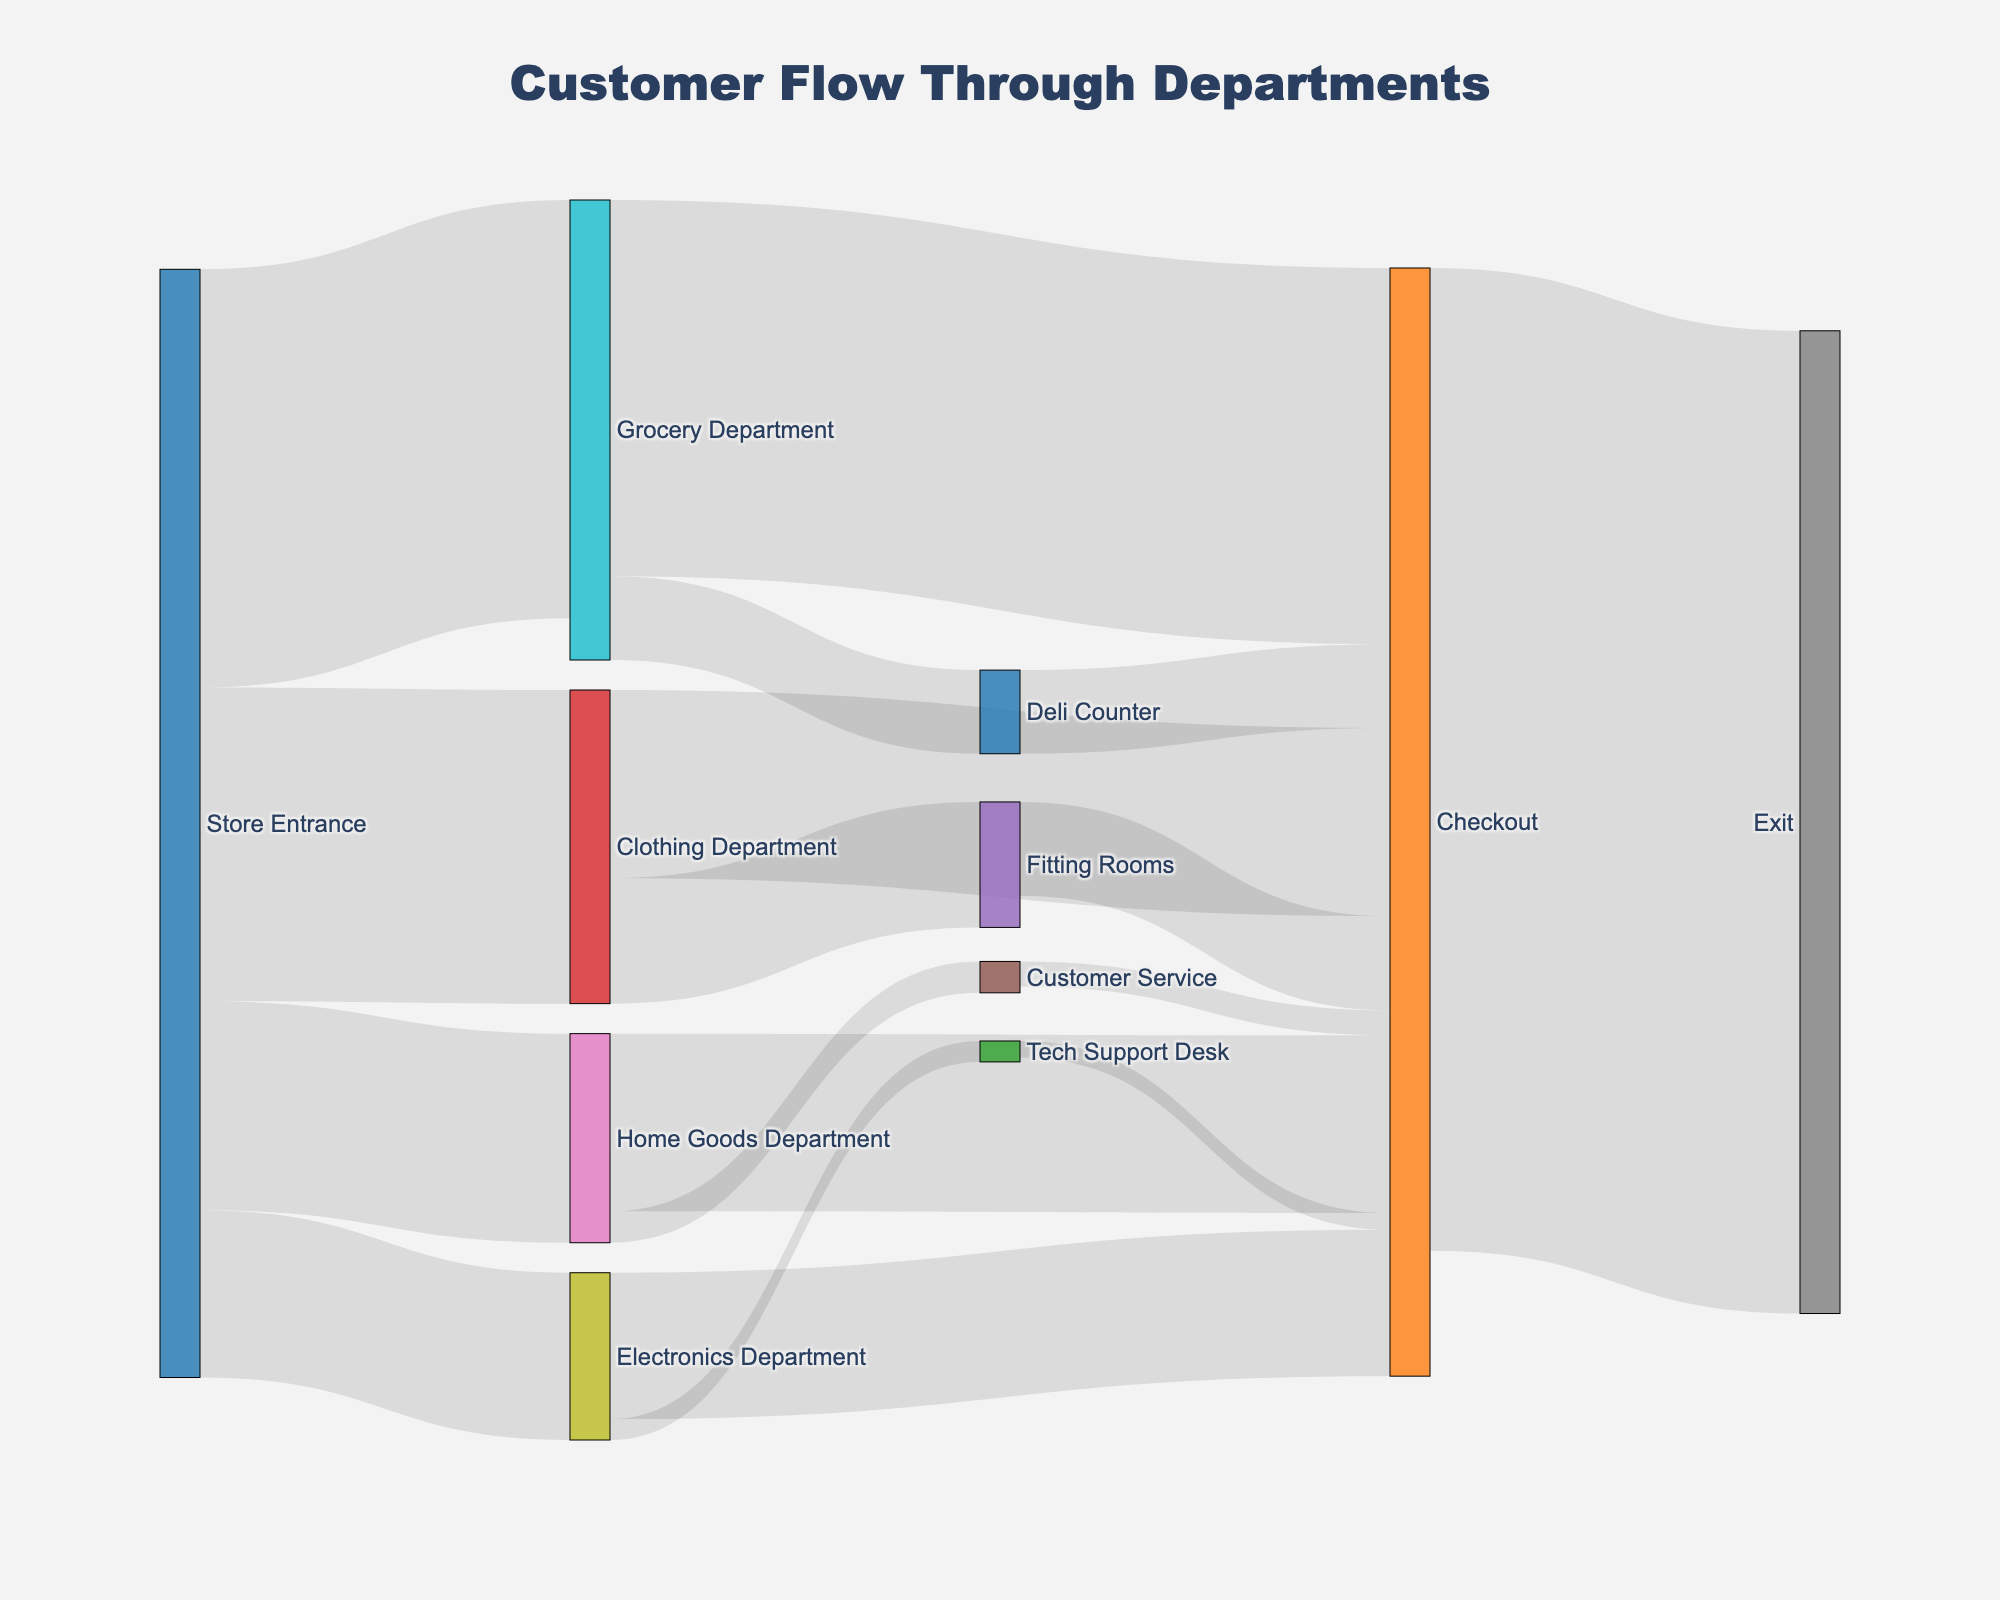Which department receives the highest number of customers entering from the Store Entrance? You can see from the figure that the customer flows from the Store Entrance. By comparing the values flowing into each department, you'll find that the Grocery Department has the highest value at 200.
Answer: Grocery Department What is the total number of customers who enter the store? Add up all the values flowing from the Store Entrance, which are 150 (Clothing Department) + 80 (Electronics Department) + 100 (Home Goods Department) + 200 (Grocery Department). The total is 530.
Answer: 530 How many customers go from the Clothing Department to the Fitting Rooms? Check the flow originating from the Clothing Department and observe the value pointing towards the Fitting Rooms, which is 60.
Answer: 60 Which department has more customers heading to the Checkout, Electronics or Home Goods? Compare the customer flow values from Electronics Department to Checkout (70) and from Home Goods Department to Checkout (85). The Home Goods Department has more.
Answer: Home Goods Department How many customers exit the store through the Checkout? Sum up the values flowing into the Checkout, then cross-check with the value exiting from Checkout. The value is 470 as indicated by the flow from Checkout to Exit.
Answer: 470 How many customers visit the Tech Support Desk from the Electronics Department? Look at the division of flow from the Electronics Department and see the value heading to the Tech Support Desk, which is 10.
Answer: 10 What is the total number of customers served at the Deli Counter? Determine the customer flow to the Deli Counter, which is from the Grocery Department. The value specified is 40.
Answer: 40 How many customers use the Fitting Rooms and then proceed to the Checkout? Identify the flow from Fitting Rooms to Checkout. The value given is 45.
Answer: 45 Between the Home Goods Department and the Grocery Department, which department directs more customers to other services or departments before reaching Checkout? Observe the flows from both departments. The Home Goods Department has flows to Customer Service (15) plus initial Checkout (85), totaling 100. The Grocery Department has flows to Deli Counter (40) and initial Checkout (180), totaling 220. Clearly, the Grocery Department redirects more customers before they reach Checkout.
Answer: Grocery Department 